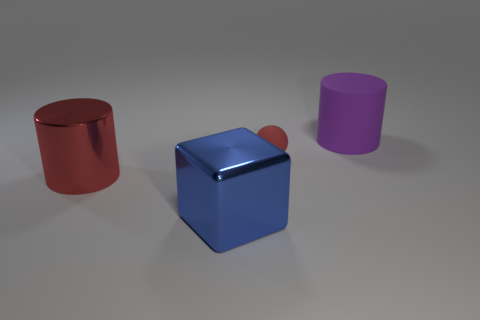Can you describe the colors and shapes visible in this image? The image showcases three prominent shapes: a cylinder on the left with a glossy, red surface; a central cube with a reflective blue exterior and a shiny, red sphere on top; and another cylinder on the right with a matte, purple surface. The background is neutral, providing contrast to the vivid colors of the objects. 